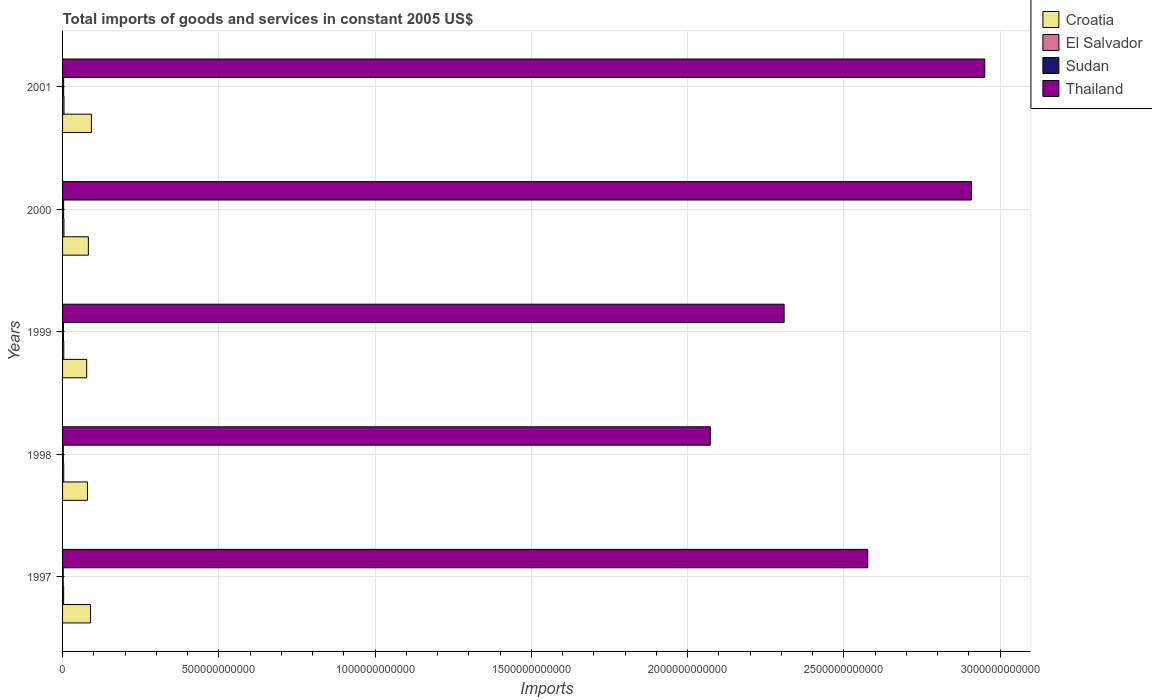How many groups of bars are there?
Your answer should be very brief. 5. Are the number of bars per tick equal to the number of legend labels?
Your answer should be compact. Yes. Are the number of bars on each tick of the Y-axis equal?
Provide a succinct answer. Yes. What is the total imports of goods and services in Thailand in 1999?
Keep it short and to the point. 2.31e+12. Across all years, what is the maximum total imports of goods and services in Thailand?
Keep it short and to the point. 2.95e+12. Across all years, what is the minimum total imports of goods and services in Thailand?
Offer a terse response. 2.07e+12. In which year was the total imports of goods and services in El Salvador maximum?
Provide a short and direct response. 2001. What is the total total imports of goods and services in Croatia in the graph?
Provide a succinct answer. 4.21e+11. What is the difference between the total imports of goods and services in Sudan in 2000 and that in 2001?
Give a very brief answer. 4.55e+06. What is the difference between the total imports of goods and services in Croatia in 2000 and the total imports of goods and services in El Salvador in 1998?
Provide a succinct answer. 7.88e+1. What is the average total imports of goods and services in Croatia per year?
Offer a very short reply. 8.42e+1. In the year 2000, what is the difference between the total imports of goods and services in El Salvador and total imports of goods and services in Thailand?
Provide a short and direct response. -2.90e+12. What is the ratio of the total imports of goods and services in Thailand in 1998 to that in 2000?
Your response must be concise. 0.71. Is the difference between the total imports of goods and services in El Salvador in 1999 and 2000 greater than the difference between the total imports of goods and services in Thailand in 1999 and 2000?
Offer a terse response. Yes. What is the difference between the highest and the second highest total imports of goods and services in Sudan?
Offer a very short reply. 4.55e+06. What is the difference between the highest and the lowest total imports of goods and services in Sudan?
Your answer should be compact. 1.35e+09. In how many years, is the total imports of goods and services in Sudan greater than the average total imports of goods and services in Sudan taken over all years?
Your answer should be compact. 2. Is the sum of the total imports of goods and services in El Salvador in 1999 and 2000 greater than the maximum total imports of goods and services in Croatia across all years?
Offer a very short reply. No. Is it the case that in every year, the sum of the total imports of goods and services in Croatia and total imports of goods and services in Thailand is greater than the sum of total imports of goods and services in El Salvador and total imports of goods and services in Sudan?
Provide a short and direct response. No. What does the 2nd bar from the top in 1998 represents?
Your response must be concise. Sudan. What does the 2nd bar from the bottom in 1999 represents?
Provide a succinct answer. El Salvador. Is it the case that in every year, the sum of the total imports of goods and services in Sudan and total imports of goods and services in Thailand is greater than the total imports of goods and services in El Salvador?
Provide a succinct answer. Yes. Are all the bars in the graph horizontal?
Your answer should be compact. Yes. What is the difference between two consecutive major ticks on the X-axis?
Offer a very short reply. 5.00e+11. Are the values on the major ticks of X-axis written in scientific E-notation?
Offer a terse response. No. Where does the legend appear in the graph?
Your answer should be compact. Top right. How many legend labels are there?
Your response must be concise. 4. What is the title of the graph?
Your answer should be very brief. Total imports of goods and services in constant 2005 US$. What is the label or title of the X-axis?
Provide a short and direct response. Imports. What is the label or title of the Y-axis?
Provide a short and direct response. Years. What is the Imports of Croatia in 1997?
Ensure brevity in your answer.  8.93e+1. What is the Imports of El Salvador in 1997?
Offer a very short reply. 3.44e+09. What is the Imports of Sudan in 1997?
Ensure brevity in your answer.  2.02e+09. What is the Imports of Thailand in 1997?
Offer a terse response. 2.58e+12. What is the Imports in Croatia in 1998?
Ensure brevity in your answer.  7.97e+1. What is the Imports of El Salvador in 1998?
Provide a short and direct response. 3.76e+09. What is the Imports in Sudan in 1998?
Ensure brevity in your answer.  2.40e+09. What is the Imports of Thailand in 1998?
Make the answer very short. 2.07e+12. What is the Imports of Croatia in 1999?
Offer a very short reply. 7.72e+1. What is the Imports in El Salvador in 1999?
Your answer should be very brief. 3.86e+09. What is the Imports in Sudan in 1999?
Give a very brief answer. 2.71e+09. What is the Imports of Thailand in 1999?
Provide a succinct answer. 2.31e+12. What is the Imports in Croatia in 2000?
Keep it short and to the point. 8.26e+1. What is the Imports of El Salvador in 2000?
Ensure brevity in your answer.  4.42e+09. What is the Imports of Sudan in 2000?
Provide a succinct answer. 3.37e+09. What is the Imports in Thailand in 2000?
Provide a short and direct response. 2.91e+12. What is the Imports of Croatia in 2001?
Ensure brevity in your answer.  9.24e+1. What is the Imports of El Salvador in 2001?
Ensure brevity in your answer.  4.61e+09. What is the Imports of Sudan in 2001?
Offer a very short reply. 3.37e+09. What is the Imports of Thailand in 2001?
Make the answer very short. 2.95e+12. Across all years, what is the maximum Imports in Croatia?
Provide a short and direct response. 9.24e+1. Across all years, what is the maximum Imports of El Salvador?
Your response must be concise. 4.61e+09. Across all years, what is the maximum Imports of Sudan?
Give a very brief answer. 3.37e+09. Across all years, what is the maximum Imports in Thailand?
Give a very brief answer. 2.95e+12. Across all years, what is the minimum Imports in Croatia?
Your answer should be compact. 7.72e+1. Across all years, what is the minimum Imports of El Salvador?
Ensure brevity in your answer.  3.44e+09. Across all years, what is the minimum Imports of Sudan?
Offer a terse response. 2.02e+09. Across all years, what is the minimum Imports in Thailand?
Your response must be concise. 2.07e+12. What is the total Imports in Croatia in the graph?
Your response must be concise. 4.21e+11. What is the total Imports in El Salvador in the graph?
Keep it short and to the point. 2.01e+1. What is the total Imports in Sudan in the graph?
Ensure brevity in your answer.  1.39e+1. What is the total Imports of Thailand in the graph?
Provide a short and direct response. 1.28e+13. What is the difference between the Imports of Croatia in 1997 and that in 1998?
Your answer should be compact. 9.61e+09. What is the difference between the Imports of El Salvador in 1997 and that in 1998?
Keep it short and to the point. -3.17e+08. What is the difference between the Imports in Sudan in 1997 and that in 1998?
Give a very brief answer. -3.75e+08. What is the difference between the Imports of Thailand in 1997 and that in 1998?
Provide a succinct answer. 5.04e+11. What is the difference between the Imports of Croatia in 1997 and that in 1999?
Offer a very short reply. 1.21e+1. What is the difference between the Imports of El Salvador in 1997 and that in 1999?
Your answer should be very brief. -4.18e+08. What is the difference between the Imports of Sudan in 1997 and that in 1999?
Provide a succinct answer. -6.88e+08. What is the difference between the Imports of Thailand in 1997 and that in 1999?
Your answer should be very brief. 2.68e+11. What is the difference between the Imports of Croatia in 1997 and that in 2000?
Provide a succinct answer. 6.72e+09. What is the difference between the Imports of El Salvador in 1997 and that in 2000?
Keep it short and to the point. -9.79e+08. What is the difference between the Imports of Sudan in 1997 and that in 2000?
Ensure brevity in your answer.  -1.35e+09. What is the difference between the Imports of Thailand in 1997 and that in 2000?
Offer a very short reply. -3.32e+11. What is the difference between the Imports of Croatia in 1997 and that in 2001?
Your answer should be very brief. -3.04e+09. What is the difference between the Imports of El Salvador in 1997 and that in 2001?
Offer a very short reply. -1.17e+09. What is the difference between the Imports in Sudan in 1997 and that in 2001?
Give a very brief answer. -1.34e+09. What is the difference between the Imports of Thailand in 1997 and that in 2001?
Keep it short and to the point. -3.74e+11. What is the difference between the Imports in Croatia in 1998 and that in 1999?
Offer a terse response. 2.53e+09. What is the difference between the Imports of El Salvador in 1998 and that in 1999?
Give a very brief answer. -1.02e+08. What is the difference between the Imports in Sudan in 1998 and that in 1999?
Give a very brief answer. -3.13e+08. What is the difference between the Imports in Thailand in 1998 and that in 1999?
Offer a terse response. -2.36e+11. What is the difference between the Imports in Croatia in 1998 and that in 2000?
Ensure brevity in your answer.  -2.89e+09. What is the difference between the Imports in El Salvador in 1998 and that in 2000?
Offer a very short reply. -6.63e+08. What is the difference between the Imports of Sudan in 1998 and that in 2000?
Ensure brevity in your answer.  -9.72e+08. What is the difference between the Imports in Thailand in 1998 and that in 2000?
Give a very brief answer. -8.36e+11. What is the difference between the Imports of Croatia in 1998 and that in 2001?
Keep it short and to the point. -1.27e+1. What is the difference between the Imports of El Salvador in 1998 and that in 2001?
Provide a short and direct response. -8.50e+08. What is the difference between the Imports in Sudan in 1998 and that in 2001?
Keep it short and to the point. -9.67e+08. What is the difference between the Imports in Thailand in 1998 and that in 2001?
Your response must be concise. -8.78e+11. What is the difference between the Imports of Croatia in 1999 and that in 2000?
Your response must be concise. -5.43e+09. What is the difference between the Imports in El Salvador in 1999 and that in 2000?
Offer a terse response. -5.61e+08. What is the difference between the Imports in Sudan in 1999 and that in 2000?
Ensure brevity in your answer.  -6.59e+08. What is the difference between the Imports in Thailand in 1999 and that in 2000?
Your response must be concise. -5.99e+11. What is the difference between the Imports in Croatia in 1999 and that in 2001?
Your answer should be compact. -1.52e+1. What is the difference between the Imports of El Salvador in 1999 and that in 2001?
Your answer should be very brief. -7.48e+08. What is the difference between the Imports of Sudan in 1999 and that in 2001?
Offer a terse response. -6.55e+08. What is the difference between the Imports of Thailand in 1999 and that in 2001?
Your answer should be very brief. -6.42e+11. What is the difference between the Imports of Croatia in 2000 and that in 2001?
Give a very brief answer. -9.77e+09. What is the difference between the Imports in El Salvador in 2000 and that in 2001?
Your response must be concise. -1.87e+08. What is the difference between the Imports in Sudan in 2000 and that in 2001?
Offer a very short reply. 4.55e+06. What is the difference between the Imports in Thailand in 2000 and that in 2001?
Give a very brief answer. -4.27e+1. What is the difference between the Imports in Croatia in 1997 and the Imports in El Salvador in 1998?
Provide a short and direct response. 8.56e+1. What is the difference between the Imports of Croatia in 1997 and the Imports of Sudan in 1998?
Your answer should be compact. 8.69e+1. What is the difference between the Imports of Croatia in 1997 and the Imports of Thailand in 1998?
Ensure brevity in your answer.  -1.98e+12. What is the difference between the Imports in El Salvador in 1997 and the Imports in Sudan in 1998?
Make the answer very short. 1.04e+09. What is the difference between the Imports in El Salvador in 1997 and the Imports in Thailand in 1998?
Ensure brevity in your answer.  -2.07e+12. What is the difference between the Imports in Sudan in 1997 and the Imports in Thailand in 1998?
Provide a short and direct response. -2.07e+12. What is the difference between the Imports of Croatia in 1997 and the Imports of El Salvador in 1999?
Offer a very short reply. 8.55e+1. What is the difference between the Imports of Croatia in 1997 and the Imports of Sudan in 1999?
Your answer should be very brief. 8.66e+1. What is the difference between the Imports of Croatia in 1997 and the Imports of Thailand in 1999?
Ensure brevity in your answer.  -2.22e+12. What is the difference between the Imports of El Salvador in 1997 and the Imports of Sudan in 1999?
Keep it short and to the point. 7.28e+08. What is the difference between the Imports in El Salvador in 1997 and the Imports in Thailand in 1999?
Offer a very short reply. -2.31e+12. What is the difference between the Imports in Sudan in 1997 and the Imports in Thailand in 1999?
Provide a succinct answer. -2.31e+12. What is the difference between the Imports of Croatia in 1997 and the Imports of El Salvador in 2000?
Your answer should be very brief. 8.49e+1. What is the difference between the Imports in Croatia in 1997 and the Imports in Sudan in 2000?
Ensure brevity in your answer.  8.60e+1. What is the difference between the Imports in Croatia in 1997 and the Imports in Thailand in 2000?
Give a very brief answer. -2.82e+12. What is the difference between the Imports in El Salvador in 1997 and the Imports in Sudan in 2000?
Your response must be concise. 6.86e+07. What is the difference between the Imports in El Salvador in 1997 and the Imports in Thailand in 2000?
Keep it short and to the point. -2.90e+12. What is the difference between the Imports of Sudan in 1997 and the Imports of Thailand in 2000?
Your answer should be very brief. -2.91e+12. What is the difference between the Imports in Croatia in 1997 and the Imports in El Salvador in 2001?
Your answer should be compact. 8.47e+1. What is the difference between the Imports of Croatia in 1997 and the Imports of Sudan in 2001?
Keep it short and to the point. 8.60e+1. What is the difference between the Imports in Croatia in 1997 and the Imports in Thailand in 2001?
Your response must be concise. -2.86e+12. What is the difference between the Imports in El Salvador in 1997 and the Imports in Sudan in 2001?
Offer a very short reply. 7.31e+07. What is the difference between the Imports of El Salvador in 1997 and the Imports of Thailand in 2001?
Make the answer very short. -2.95e+12. What is the difference between the Imports in Sudan in 1997 and the Imports in Thailand in 2001?
Ensure brevity in your answer.  -2.95e+12. What is the difference between the Imports of Croatia in 1998 and the Imports of El Salvador in 1999?
Ensure brevity in your answer.  7.59e+1. What is the difference between the Imports of Croatia in 1998 and the Imports of Sudan in 1999?
Offer a terse response. 7.70e+1. What is the difference between the Imports in Croatia in 1998 and the Imports in Thailand in 1999?
Provide a short and direct response. -2.23e+12. What is the difference between the Imports of El Salvador in 1998 and the Imports of Sudan in 1999?
Your answer should be compact. 1.04e+09. What is the difference between the Imports of El Salvador in 1998 and the Imports of Thailand in 1999?
Keep it short and to the point. -2.30e+12. What is the difference between the Imports of Sudan in 1998 and the Imports of Thailand in 1999?
Your answer should be very brief. -2.31e+12. What is the difference between the Imports of Croatia in 1998 and the Imports of El Salvador in 2000?
Offer a terse response. 7.53e+1. What is the difference between the Imports of Croatia in 1998 and the Imports of Sudan in 2000?
Provide a short and direct response. 7.63e+1. What is the difference between the Imports in Croatia in 1998 and the Imports in Thailand in 2000?
Offer a terse response. -2.83e+12. What is the difference between the Imports in El Salvador in 1998 and the Imports in Sudan in 2000?
Give a very brief answer. 3.85e+08. What is the difference between the Imports of El Salvador in 1998 and the Imports of Thailand in 2000?
Your response must be concise. -2.90e+12. What is the difference between the Imports in Sudan in 1998 and the Imports in Thailand in 2000?
Your answer should be very brief. -2.91e+12. What is the difference between the Imports in Croatia in 1998 and the Imports in El Salvador in 2001?
Your response must be concise. 7.51e+1. What is the difference between the Imports in Croatia in 1998 and the Imports in Sudan in 2001?
Offer a terse response. 7.63e+1. What is the difference between the Imports in Croatia in 1998 and the Imports in Thailand in 2001?
Make the answer very short. -2.87e+12. What is the difference between the Imports in El Salvador in 1998 and the Imports in Sudan in 2001?
Provide a short and direct response. 3.90e+08. What is the difference between the Imports in El Salvador in 1998 and the Imports in Thailand in 2001?
Ensure brevity in your answer.  -2.95e+12. What is the difference between the Imports of Sudan in 1998 and the Imports of Thailand in 2001?
Offer a very short reply. -2.95e+12. What is the difference between the Imports of Croatia in 1999 and the Imports of El Salvador in 2000?
Keep it short and to the point. 7.28e+1. What is the difference between the Imports in Croatia in 1999 and the Imports in Sudan in 2000?
Make the answer very short. 7.38e+1. What is the difference between the Imports in Croatia in 1999 and the Imports in Thailand in 2000?
Keep it short and to the point. -2.83e+12. What is the difference between the Imports in El Salvador in 1999 and the Imports in Sudan in 2000?
Provide a succinct answer. 4.87e+08. What is the difference between the Imports of El Salvador in 1999 and the Imports of Thailand in 2000?
Offer a terse response. -2.90e+12. What is the difference between the Imports of Sudan in 1999 and the Imports of Thailand in 2000?
Your answer should be compact. -2.91e+12. What is the difference between the Imports in Croatia in 1999 and the Imports in El Salvador in 2001?
Your answer should be very brief. 7.26e+1. What is the difference between the Imports of Croatia in 1999 and the Imports of Sudan in 2001?
Your answer should be very brief. 7.38e+1. What is the difference between the Imports in Croatia in 1999 and the Imports in Thailand in 2001?
Offer a terse response. -2.87e+12. What is the difference between the Imports in El Salvador in 1999 and the Imports in Sudan in 2001?
Ensure brevity in your answer.  4.92e+08. What is the difference between the Imports in El Salvador in 1999 and the Imports in Thailand in 2001?
Offer a very short reply. -2.95e+12. What is the difference between the Imports in Sudan in 1999 and the Imports in Thailand in 2001?
Offer a terse response. -2.95e+12. What is the difference between the Imports in Croatia in 2000 and the Imports in El Salvador in 2001?
Keep it short and to the point. 7.80e+1. What is the difference between the Imports in Croatia in 2000 and the Imports in Sudan in 2001?
Offer a very short reply. 7.92e+1. What is the difference between the Imports of Croatia in 2000 and the Imports of Thailand in 2001?
Your response must be concise. -2.87e+12. What is the difference between the Imports in El Salvador in 2000 and the Imports in Sudan in 2001?
Provide a short and direct response. 1.05e+09. What is the difference between the Imports of El Salvador in 2000 and the Imports of Thailand in 2001?
Offer a very short reply. -2.95e+12. What is the difference between the Imports in Sudan in 2000 and the Imports in Thailand in 2001?
Make the answer very short. -2.95e+12. What is the average Imports in Croatia per year?
Your answer should be compact. 8.42e+1. What is the average Imports of El Salvador per year?
Offer a very short reply. 4.02e+09. What is the average Imports of Sudan per year?
Ensure brevity in your answer.  2.77e+09. What is the average Imports of Thailand per year?
Your answer should be very brief. 2.56e+12. In the year 1997, what is the difference between the Imports of Croatia and Imports of El Salvador?
Offer a terse response. 8.59e+1. In the year 1997, what is the difference between the Imports in Croatia and Imports in Sudan?
Your answer should be compact. 8.73e+1. In the year 1997, what is the difference between the Imports in Croatia and Imports in Thailand?
Ensure brevity in your answer.  -2.49e+12. In the year 1997, what is the difference between the Imports in El Salvador and Imports in Sudan?
Provide a succinct answer. 1.42e+09. In the year 1997, what is the difference between the Imports of El Salvador and Imports of Thailand?
Keep it short and to the point. -2.57e+12. In the year 1997, what is the difference between the Imports in Sudan and Imports in Thailand?
Provide a short and direct response. -2.57e+12. In the year 1998, what is the difference between the Imports in Croatia and Imports in El Salvador?
Your answer should be compact. 7.60e+1. In the year 1998, what is the difference between the Imports in Croatia and Imports in Sudan?
Ensure brevity in your answer.  7.73e+1. In the year 1998, what is the difference between the Imports in Croatia and Imports in Thailand?
Give a very brief answer. -1.99e+12. In the year 1998, what is the difference between the Imports in El Salvador and Imports in Sudan?
Provide a succinct answer. 1.36e+09. In the year 1998, what is the difference between the Imports in El Salvador and Imports in Thailand?
Offer a very short reply. -2.07e+12. In the year 1998, what is the difference between the Imports of Sudan and Imports of Thailand?
Offer a terse response. -2.07e+12. In the year 1999, what is the difference between the Imports of Croatia and Imports of El Salvador?
Provide a succinct answer. 7.33e+1. In the year 1999, what is the difference between the Imports in Croatia and Imports in Sudan?
Keep it short and to the point. 7.45e+1. In the year 1999, what is the difference between the Imports in Croatia and Imports in Thailand?
Offer a very short reply. -2.23e+12. In the year 1999, what is the difference between the Imports in El Salvador and Imports in Sudan?
Ensure brevity in your answer.  1.15e+09. In the year 1999, what is the difference between the Imports of El Salvador and Imports of Thailand?
Offer a terse response. -2.30e+12. In the year 1999, what is the difference between the Imports in Sudan and Imports in Thailand?
Ensure brevity in your answer.  -2.31e+12. In the year 2000, what is the difference between the Imports of Croatia and Imports of El Salvador?
Your answer should be compact. 7.82e+1. In the year 2000, what is the difference between the Imports in Croatia and Imports in Sudan?
Keep it short and to the point. 7.92e+1. In the year 2000, what is the difference between the Imports of Croatia and Imports of Thailand?
Your response must be concise. -2.83e+12. In the year 2000, what is the difference between the Imports of El Salvador and Imports of Sudan?
Your answer should be very brief. 1.05e+09. In the year 2000, what is the difference between the Imports of El Salvador and Imports of Thailand?
Provide a succinct answer. -2.90e+12. In the year 2000, what is the difference between the Imports of Sudan and Imports of Thailand?
Provide a short and direct response. -2.90e+12. In the year 2001, what is the difference between the Imports in Croatia and Imports in El Salvador?
Offer a terse response. 8.78e+1. In the year 2001, what is the difference between the Imports of Croatia and Imports of Sudan?
Your answer should be very brief. 8.90e+1. In the year 2001, what is the difference between the Imports in Croatia and Imports in Thailand?
Give a very brief answer. -2.86e+12. In the year 2001, what is the difference between the Imports of El Salvador and Imports of Sudan?
Provide a succinct answer. 1.24e+09. In the year 2001, what is the difference between the Imports of El Salvador and Imports of Thailand?
Provide a short and direct response. -2.95e+12. In the year 2001, what is the difference between the Imports in Sudan and Imports in Thailand?
Offer a terse response. -2.95e+12. What is the ratio of the Imports of Croatia in 1997 to that in 1998?
Keep it short and to the point. 1.12. What is the ratio of the Imports of El Salvador in 1997 to that in 1998?
Ensure brevity in your answer.  0.92. What is the ratio of the Imports in Sudan in 1997 to that in 1998?
Offer a terse response. 0.84. What is the ratio of the Imports of Thailand in 1997 to that in 1998?
Keep it short and to the point. 1.24. What is the ratio of the Imports of Croatia in 1997 to that in 1999?
Provide a short and direct response. 1.16. What is the ratio of the Imports in El Salvador in 1997 to that in 1999?
Make the answer very short. 0.89. What is the ratio of the Imports of Sudan in 1997 to that in 1999?
Offer a very short reply. 0.75. What is the ratio of the Imports of Thailand in 1997 to that in 1999?
Make the answer very short. 1.12. What is the ratio of the Imports of Croatia in 1997 to that in 2000?
Your answer should be compact. 1.08. What is the ratio of the Imports of El Salvador in 1997 to that in 2000?
Provide a succinct answer. 0.78. What is the ratio of the Imports in Sudan in 1997 to that in 2000?
Make the answer very short. 0.6. What is the ratio of the Imports in Thailand in 1997 to that in 2000?
Keep it short and to the point. 0.89. What is the ratio of the Imports of El Salvador in 1997 to that in 2001?
Ensure brevity in your answer.  0.75. What is the ratio of the Imports in Sudan in 1997 to that in 2001?
Your response must be concise. 0.6. What is the ratio of the Imports in Thailand in 1997 to that in 2001?
Ensure brevity in your answer.  0.87. What is the ratio of the Imports in Croatia in 1998 to that in 1999?
Give a very brief answer. 1.03. What is the ratio of the Imports in El Salvador in 1998 to that in 1999?
Make the answer very short. 0.97. What is the ratio of the Imports in Sudan in 1998 to that in 1999?
Offer a very short reply. 0.88. What is the ratio of the Imports of Thailand in 1998 to that in 1999?
Your response must be concise. 0.9. What is the ratio of the Imports in Croatia in 1998 to that in 2000?
Make the answer very short. 0.96. What is the ratio of the Imports of El Salvador in 1998 to that in 2000?
Provide a short and direct response. 0.85. What is the ratio of the Imports in Sudan in 1998 to that in 2000?
Ensure brevity in your answer.  0.71. What is the ratio of the Imports of Thailand in 1998 to that in 2000?
Your answer should be compact. 0.71. What is the ratio of the Imports of Croatia in 1998 to that in 2001?
Offer a terse response. 0.86. What is the ratio of the Imports of El Salvador in 1998 to that in 2001?
Ensure brevity in your answer.  0.82. What is the ratio of the Imports of Sudan in 1998 to that in 2001?
Provide a succinct answer. 0.71. What is the ratio of the Imports of Thailand in 1998 to that in 2001?
Give a very brief answer. 0.7. What is the ratio of the Imports in Croatia in 1999 to that in 2000?
Ensure brevity in your answer.  0.93. What is the ratio of the Imports in El Salvador in 1999 to that in 2000?
Provide a succinct answer. 0.87. What is the ratio of the Imports in Sudan in 1999 to that in 2000?
Offer a terse response. 0.8. What is the ratio of the Imports in Thailand in 1999 to that in 2000?
Your answer should be compact. 0.79. What is the ratio of the Imports of Croatia in 1999 to that in 2001?
Offer a very short reply. 0.84. What is the ratio of the Imports in El Salvador in 1999 to that in 2001?
Your answer should be very brief. 0.84. What is the ratio of the Imports in Sudan in 1999 to that in 2001?
Make the answer very short. 0.81. What is the ratio of the Imports of Thailand in 1999 to that in 2001?
Provide a succinct answer. 0.78. What is the ratio of the Imports in Croatia in 2000 to that in 2001?
Keep it short and to the point. 0.89. What is the ratio of the Imports in El Salvador in 2000 to that in 2001?
Ensure brevity in your answer.  0.96. What is the ratio of the Imports of Thailand in 2000 to that in 2001?
Offer a very short reply. 0.99. What is the difference between the highest and the second highest Imports in Croatia?
Offer a terse response. 3.04e+09. What is the difference between the highest and the second highest Imports in El Salvador?
Ensure brevity in your answer.  1.87e+08. What is the difference between the highest and the second highest Imports of Sudan?
Provide a succinct answer. 4.55e+06. What is the difference between the highest and the second highest Imports in Thailand?
Ensure brevity in your answer.  4.27e+1. What is the difference between the highest and the lowest Imports in Croatia?
Provide a short and direct response. 1.52e+1. What is the difference between the highest and the lowest Imports in El Salvador?
Provide a short and direct response. 1.17e+09. What is the difference between the highest and the lowest Imports in Sudan?
Keep it short and to the point. 1.35e+09. What is the difference between the highest and the lowest Imports of Thailand?
Ensure brevity in your answer.  8.78e+11. 